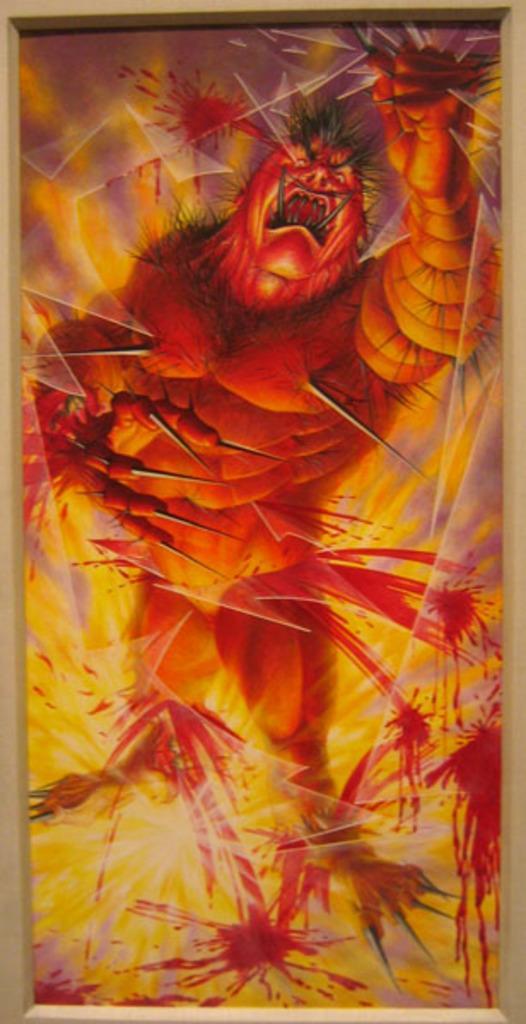Can you describe this image briefly? In the picture we can see a painting of beast, which is orange in color and behind it, we can see a fire which is yellow in color. 